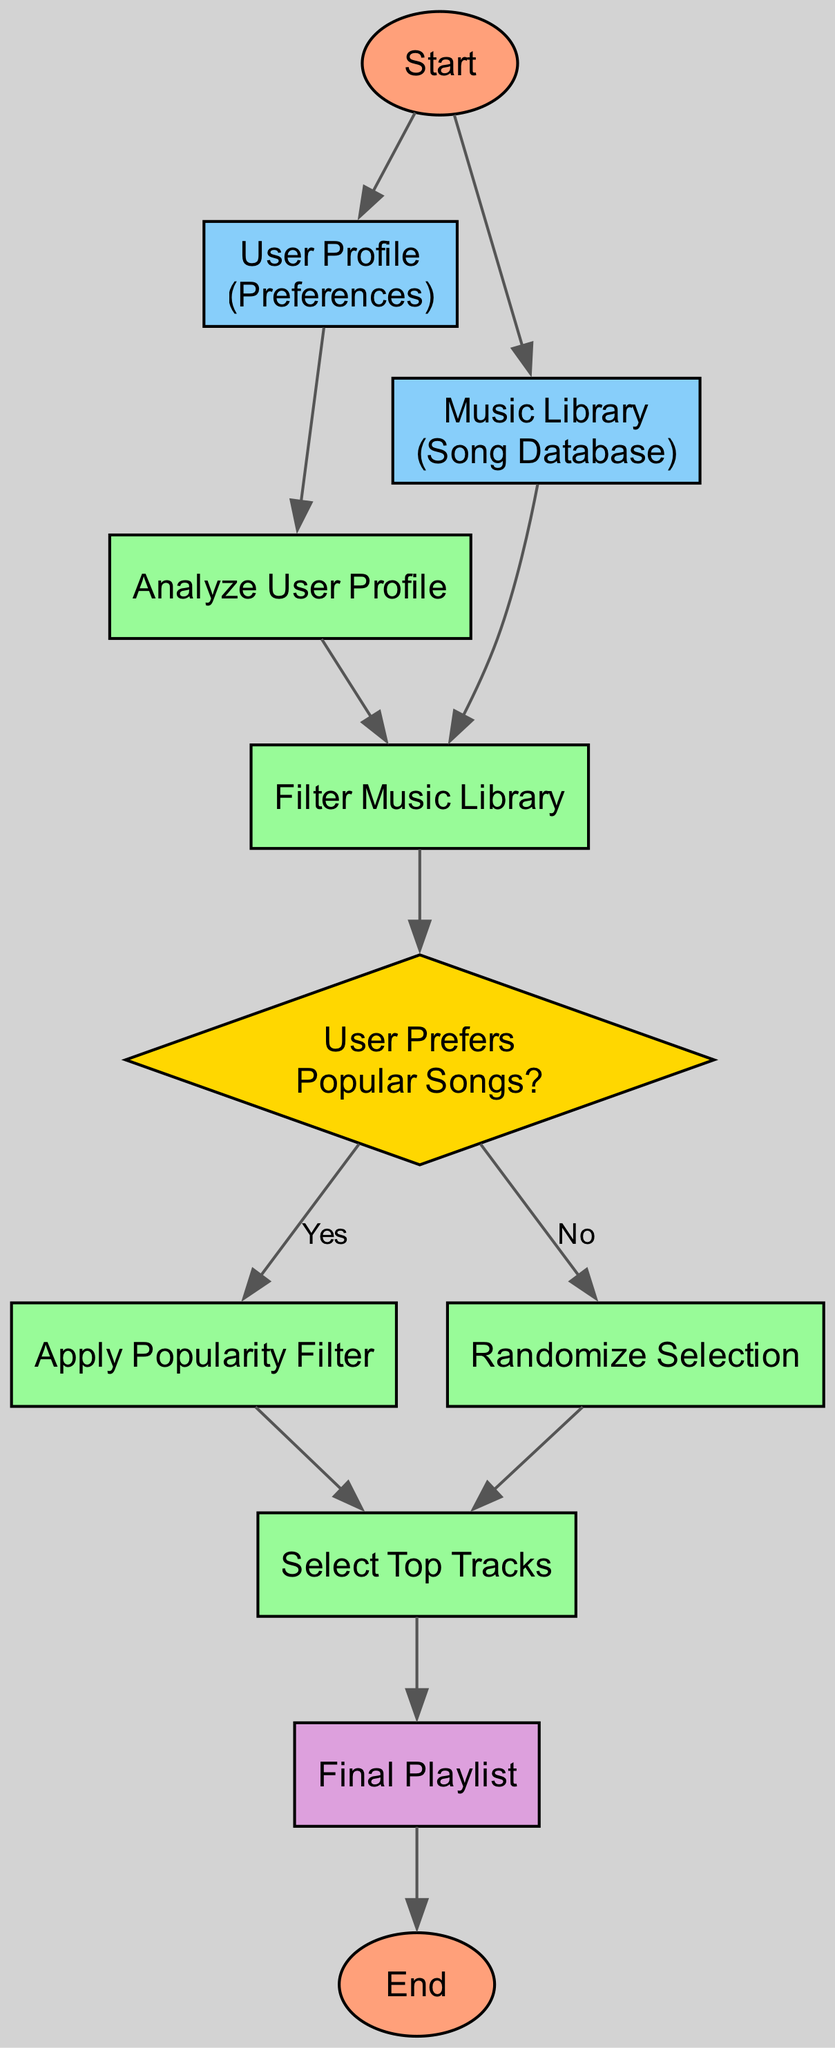What is the first step in the function? The first step in the function is to begin the function call, which is indicated by the "Start" node at the top of the diagram.
Answer: Begin the function call What type of node is "User Prefers Popular Songs?" This is a decision node, which is represented as a diamond shape in the flowchart, distinguishing it from other types of nodes like processes or outputs.
Answer: Decision How many input nodes are present in the diagram? There are two input nodes: "User Profile" and "Music Library," which gather necessary information for processing.
Answer: Two What happens if the user does not prefer popular songs? If the user does not prefer popular songs, the flow moves to the "Randomize Selection" node according to the edge labeled "No" from the decision node.
Answer: Randomize Selection Which node leads directly to the output playlist? The "Select Top Tracks" node directly leads to the "Final Playlist" output, completing the process of creating a playlist recommendation.
Answer: Select Top Tracks What process follows after "Analyze User Profile"? The process that follows is "Filter Music Library," which takes the analyzed preferences and applies them to the available music.
Answer: Filter Music Library What is the relationship between "Apply Popularity Filter" and "Select Top Tracks"? The "Apply Popularity Filter" node feeds into the "Select Top Tracks" node, meaning it is a prerequisite process before selecting the final playlist tracks.
Answer: Apply Popularity Filter How is the music library filtered? The music library is filtered based on the derived key preferences from the user profile, which is indicated in the "Filter Music Library" process.
Answer: Derived key preferences What is the purpose of the "Randomize Selection" step? The "Randomize Selection" step adds variety by shuffling the songs, ensuring the playlist is not static and offers different selections each time.
Answer: Add variety 